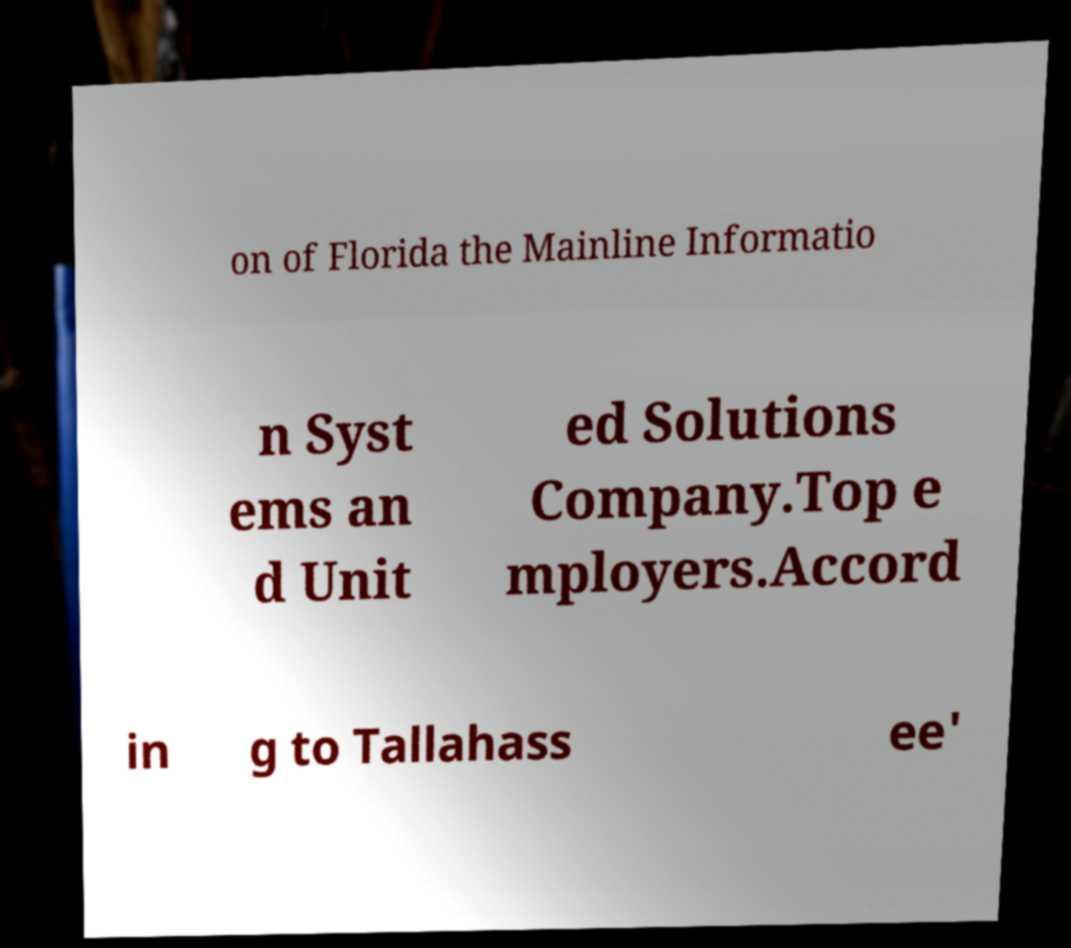Could you extract and type out the text from this image? on of Florida the Mainline Informatio n Syst ems an d Unit ed Solutions Company.Top e mployers.Accord in g to Tallahass ee' 